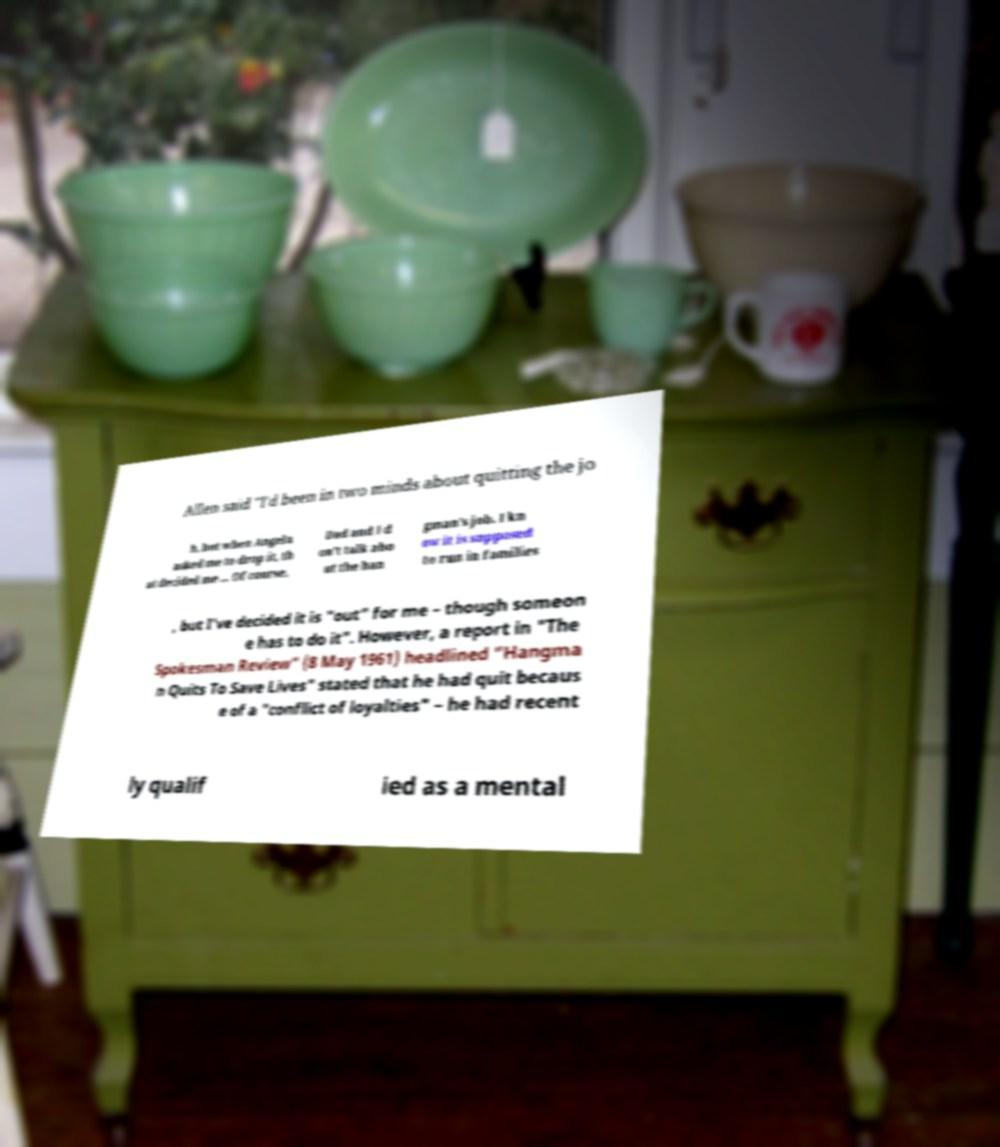Can you accurately transcribe the text from the provided image for me? Allen said "I'd been in two minds about quitting the jo b, but when Angela asked me to drop it, th at decided me ... Of course, Dad and I d on't talk abo ut the han gman's job. I kn ow it is supposed to run in families , but I've decided it is "out" for me – though someon e has to do it". However, a report in "The Spokesman Review" (8 May 1961) headlined "Hangma n Quits To Save Lives" stated that he had quit becaus e of a "conflict of loyalties" – he had recent ly qualif ied as a mental 